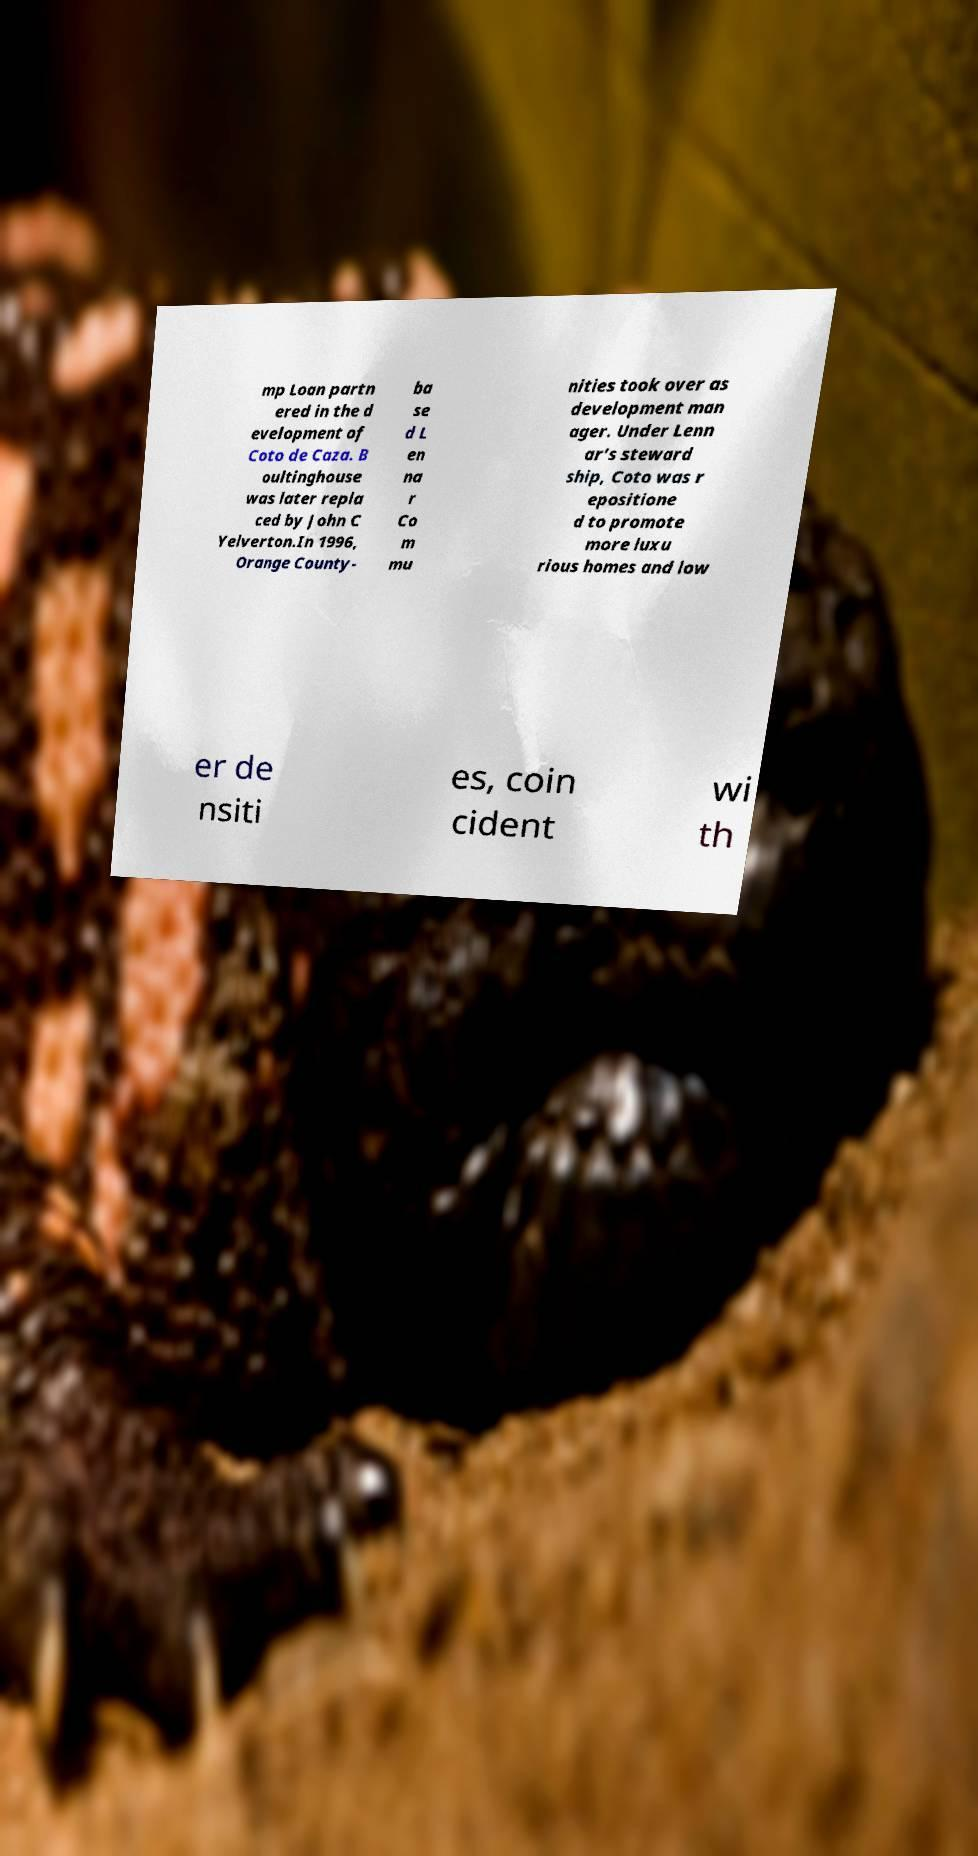I need the written content from this picture converted into text. Can you do that? mp Loan partn ered in the d evelopment of Coto de Caza. B oultinghouse was later repla ced by John C Yelverton.In 1996, Orange County- ba se d L en na r Co m mu nities took over as development man ager. Under Lenn ar’s steward ship, Coto was r epositione d to promote more luxu rious homes and low er de nsiti es, coin cident wi th 